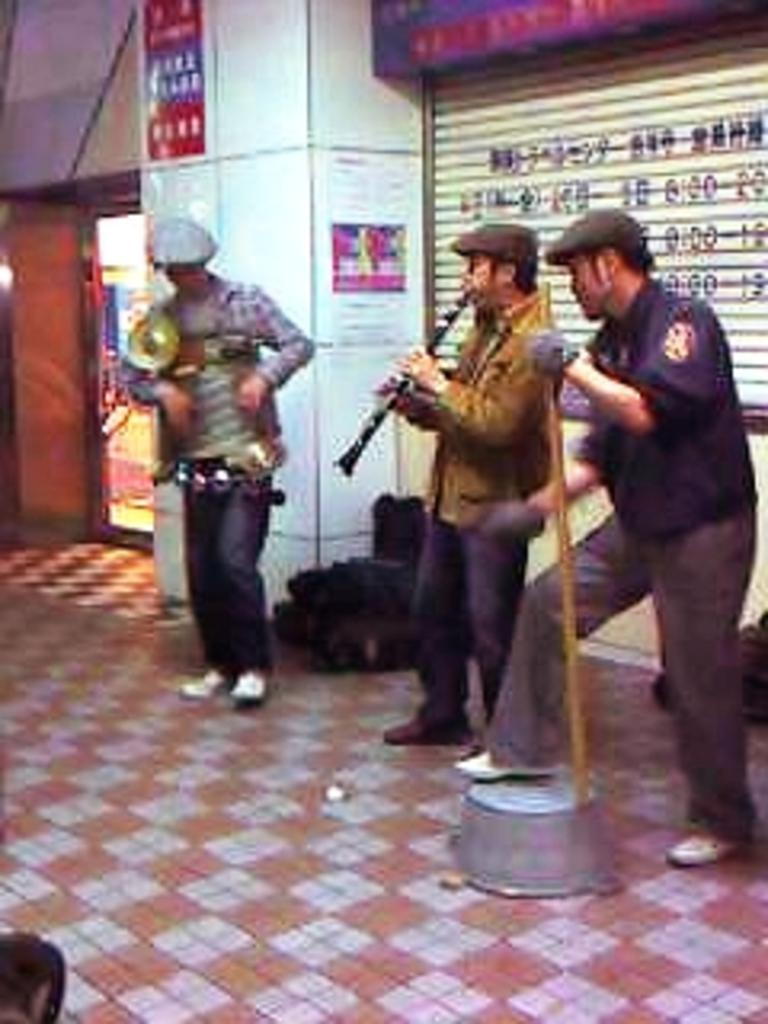How many people are in the image? There are people in the image, but the exact number is not specified. What are the people wearing on their heads? The people are wearing caps. What are the people holding in the image? The people are holding objects. What is the purpose of the shutter in the image? The purpose of the shutter is not specified, but it might be related to photography or security. What type of visuals are displayed on the posters in the image? The content of the posters is not specified. What is the board used for in the image? The purpose of the board is not specified. What type of establishment is depicted in the image? There is a store in the image. What type of cakes can be seen on the coast in the image? There is no coast or cakes present in the image. How much butter is used in the store in the image? The amount of butter used in the store is not specified in the image. 